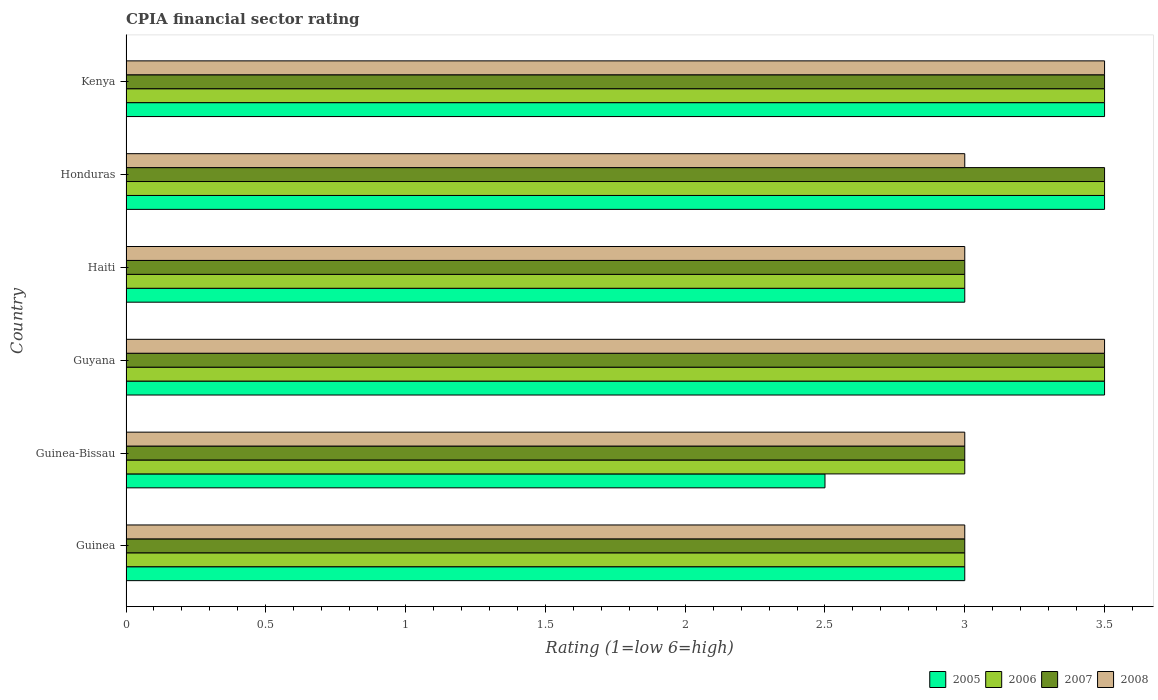How many groups of bars are there?
Your response must be concise. 6. Are the number of bars per tick equal to the number of legend labels?
Provide a short and direct response. Yes. How many bars are there on the 3rd tick from the top?
Offer a terse response. 4. How many bars are there on the 2nd tick from the bottom?
Your response must be concise. 4. What is the label of the 6th group of bars from the top?
Offer a very short reply. Guinea. Across all countries, what is the maximum CPIA rating in 2008?
Your answer should be very brief. 3.5. Across all countries, what is the minimum CPIA rating in 2008?
Keep it short and to the point. 3. In which country was the CPIA rating in 2007 maximum?
Ensure brevity in your answer.  Guyana. In which country was the CPIA rating in 2006 minimum?
Provide a succinct answer. Guinea. What is the total CPIA rating in 2006 in the graph?
Provide a succinct answer. 19.5. What is the difference between the CPIA rating in 2005 and CPIA rating in 2007 in Guyana?
Your answer should be very brief. 0. What is the ratio of the CPIA rating in 2007 in Guinea-Bissau to that in Honduras?
Your answer should be very brief. 0.86. What is the difference between the highest and the lowest CPIA rating in 2007?
Your answer should be compact. 0.5. In how many countries, is the CPIA rating in 2008 greater than the average CPIA rating in 2008 taken over all countries?
Give a very brief answer. 2. What does the 2nd bar from the bottom in Kenya represents?
Provide a short and direct response. 2006. Is it the case that in every country, the sum of the CPIA rating in 2008 and CPIA rating in 2005 is greater than the CPIA rating in 2007?
Provide a short and direct response. Yes. How many bars are there?
Give a very brief answer. 24. Are all the bars in the graph horizontal?
Keep it short and to the point. Yes. How many countries are there in the graph?
Provide a short and direct response. 6. What is the difference between two consecutive major ticks on the X-axis?
Your response must be concise. 0.5. Are the values on the major ticks of X-axis written in scientific E-notation?
Keep it short and to the point. No. Where does the legend appear in the graph?
Offer a very short reply. Bottom right. How are the legend labels stacked?
Your response must be concise. Horizontal. What is the title of the graph?
Offer a terse response. CPIA financial sector rating. What is the Rating (1=low 6=high) of 2007 in Guinea?
Give a very brief answer. 3. What is the Rating (1=low 6=high) of 2008 in Guinea?
Your answer should be very brief. 3. What is the Rating (1=low 6=high) in 2005 in Guinea-Bissau?
Offer a very short reply. 2.5. What is the Rating (1=low 6=high) in 2006 in Guinea-Bissau?
Provide a short and direct response. 3. What is the Rating (1=low 6=high) in 2007 in Guinea-Bissau?
Keep it short and to the point. 3. What is the Rating (1=low 6=high) in 2006 in Guyana?
Make the answer very short. 3.5. What is the Rating (1=low 6=high) in 2005 in Haiti?
Your response must be concise. 3. What is the Rating (1=low 6=high) in 2007 in Haiti?
Offer a terse response. 3. What is the Rating (1=low 6=high) in 2008 in Honduras?
Your answer should be very brief. 3. What is the Rating (1=low 6=high) in 2005 in Kenya?
Give a very brief answer. 3.5. What is the Rating (1=low 6=high) of 2008 in Kenya?
Your answer should be compact. 3.5. Across all countries, what is the maximum Rating (1=low 6=high) of 2006?
Ensure brevity in your answer.  3.5. Across all countries, what is the maximum Rating (1=low 6=high) in 2008?
Ensure brevity in your answer.  3.5. Across all countries, what is the minimum Rating (1=low 6=high) in 2006?
Ensure brevity in your answer.  3. What is the total Rating (1=low 6=high) in 2006 in the graph?
Offer a terse response. 19.5. What is the total Rating (1=low 6=high) of 2008 in the graph?
Give a very brief answer. 19. What is the difference between the Rating (1=low 6=high) in 2005 in Guinea and that in Guinea-Bissau?
Ensure brevity in your answer.  0.5. What is the difference between the Rating (1=low 6=high) of 2007 in Guinea and that in Guinea-Bissau?
Your answer should be compact. 0. What is the difference between the Rating (1=low 6=high) of 2008 in Guinea and that in Guinea-Bissau?
Your answer should be very brief. 0. What is the difference between the Rating (1=low 6=high) of 2008 in Guinea and that in Guyana?
Keep it short and to the point. -0.5. What is the difference between the Rating (1=low 6=high) in 2005 in Guinea and that in Honduras?
Offer a very short reply. -0.5. What is the difference between the Rating (1=low 6=high) of 2007 in Guinea and that in Honduras?
Your answer should be compact. -0.5. What is the difference between the Rating (1=low 6=high) in 2008 in Guinea and that in Honduras?
Your answer should be compact. 0. What is the difference between the Rating (1=low 6=high) of 2005 in Guinea and that in Kenya?
Keep it short and to the point. -0.5. What is the difference between the Rating (1=low 6=high) of 2006 in Guinea and that in Kenya?
Provide a succinct answer. -0.5. What is the difference between the Rating (1=low 6=high) of 2007 in Guinea and that in Kenya?
Provide a short and direct response. -0.5. What is the difference between the Rating (1=low 6=high) of 2008 in Guinea-Bissau and that in Guyana?
Provide a short and direct response. -0.5. What is the difference between the Rating (1=low 6=high) of 2005 in Guinea-Bissau and that in Haiti?
Keep it short and to the point. -0.5. What is the difference between the Rating (1=low 6=high) in 2005 in Guinea-Bissau and that in Honduras?
Make the answer very short. -1. What is the difference between the Rating (1=low 6=high) of 2007 in Guinea-Bissau and that in Honduras?
Your response must be concise. -0.5. What is the difference between the Rating (1=low 6=high) in 2006 in Guinea-Bissau and that in Kenya?
Ensure brevity in your answer.  -0.5. What is the difference between the Rating (1=low 6=high) of 2007 in Guinea-Bissau and that in Kenya?
Your answer should be very brief. -0.5. What is the difference between the Rating (1=low 6=high) of 2008 in Guinea-Bissau and that in Kenya?
Provide a succinct answer. -0.5. What is the difference between the Rating (1=low 6=high) of 2005 in Guyana and that in Honduras?
Make the answer very short. 0. What is the difference between the Rating (1=low 6=high) of 2006 in Guyana and that in Honduras?
Give a very brief answer. 0. What is the difference between the Rating (1=low 6=high) of 2005 in Guyana and that in Kenya?
Your response must be concise. 0. What is the difference between the Rating (1=low 6=high) in 2007 in Guyana and that in Kenya?
Your response must be concise. 0. What is the difference between the Rating (1=low 6=high) of 2008 in Guyana and that in Kenya?
Offer a terse response. 0. What is the difference between the Rating (1=low 6=high) of 2005 in Haiti and that in Honduras?
Give a very brief answer. -0.5. What is the difference between the Rating (1=low 6=high) in 2006 in Haiti and that in Honduras?
Make the answer very short. -0.5. What is the difference between the Rating (1=low 6=high) of 2007 in Haiti and that in Honduras?
Keep it short and to the point. -0.5. What is the difference between the Rating (1=low 6=high) in 2005 in Haiti and that in Kenya?
Provide a succinct answer. -0.5. What is the difference between the Rating (1=low 6=high) in 2007 in Haiti and that in Kenya?
Ensure brevity in your answer.  -0.5. What is the difference between the Rating (1=low 6=high) in 2008 in Haiti and that in Kenya?
Make the answer very short. -0.5. What is the difference between the Rating (1=low 6=high) of 2005 in Honduras and that in Kenya?
Ensure brevity in your answer.  0. What is the difference between the Rating (1=low 6=high) in 2007 in Honduras and that in Kenya?
Ensure brevity in your answer.  0. What is the difference between the Rating (1=low 6=high) of 2005 in Guinea and the Rating (1=low 6=high) of 2006 in Guinea-Bissau?
Your answer should be compact. 0. What is the difference between the Rating (1=low 6=high) in 2005 in Guinea and the Rating (1=low 6=high) in 2008 in Guinea-Bissau?
Make the answer very short. 0. What is the difference between the Rating (1=low 6=high) in 2006 in Guinea and the Rating (1=low 6=high) in 2007 in Guinea-Bissau?
Make the answer very short. 0. What is the difference between the Rating (1=low 6=high) of 2007 in Guinea and the Rating (1=low 6=high) of 2008 in Guinea-Bissau?
Your answer should be compact. 0. What is the difference between the Rating (1=low 6=high) in 2006 in Guinea and the Rating (1=low 6=high) in 2007 in Guyana?
Your answer should be very brief. -0.5. What is the difference between the Rating (1=low 6=high) in 2007 in Guinea and the Rating (1=low 6=high) in 2008 in Guyana?
Provide a short and direct response. -0.5. What is the difference between the Rating (1=low 6=high) in 2005 in Guinea and the Rating (1=low 6=high) in 2006 in Haiti?
Ensure brevity in your answer.  0. What is the difference between the Rating (1=low 6=high) in 2006 in Guinea and the Rating (1=low 6=high) in 2008 in Haiti?
Make the answer very short. 0. What is the difference between the Rating (1=low 6=high) of 2005 in Guinea and the Rating (1=low 6=high) of 2007 in Honduras?
Offer a very short reply. -0.5. What is the difference between the Rating (1=low 6=high) in 2006 in Guinea and the Rating (1=low 6=high) in 2007 in Honduras?
Your answer should be very brief. -0.5. What is the difference between the Rating (1=low 6=high) in 2006 in Guinea and the Rating (1=low 6=high) in 2008 in Honduras?
Keep it short and to the point. 0. What is the difference between the Rating (1=low 6=high) in 2006 in Guinea and the Rating (1=low 6=high) in 2007 in Kenya?
Provide a short and direct response. -0.5. What is the difference between the Rating (1=low 6=high) of 2006 in Guinea and the Rating (1=low 6=high) of 2008 in Kenya?
Provide a short and direct response. -0.5. What is the difference between the Rating (1=low 6=high) of 2007 in Guinea and the Rating (1=low 6=high) of 2008 in Kenya?
Ensure brevity in your answer.  -0.5. What is the difference between the Rating (1=low 6=high) of 2005 in Guinea-Bissau and the Rating (1=low 6=high) of 2007 in Guyana?
Offer a very short reply. -1. What is the difference between the Rating (1=low 6=high) in 2005 in Guinea-Bissau and the Rating (1=low 6=high) in 2008 in Guyana?
Your answer should be compact. -1. What is the difference between the Rating (1=low 6=high) in 2007 in Guinea-Bissau and the Rating (1=low 6=high) in 2008 in Guyana?
Your answer should be compact. -0.5. What is the difference between the Rating (1=low 6=high) in 2005 in Guinea-Bissau and the Rating (1=low 6=high) in 2007 in Haiti?
Make the answer very short. -0.5. What is the difference between the Rating (1=low 6=high) in 2005 in Guinea-Bissau and the Rating (1=low 6=high) in 2008 in Haiti?
Offer a terse response. -0.5. What is the difference between the Rating (1=low 6=high) in 2006 in Guinea-Bissau and the Rating (1=low 6=high) in 2007 in Haiti?
Provide a succinct answer. 0. What is the difference between the Rating (1=low 6=high) in 2006 in Guinea-Bissau and the Rating (1=low 6=high) in 2008 in Haiti?
Your answer should be very brief. 0. What is the difference between the Rating (1=low 6=high) in 2005 in Guinea-Bissau and the Rating (1=low 6=high) in 2006 in Honduras?
Keep it short and to the point. -1. What is the difference between the Rating (1=low 6=high) of 2005 in Guinea-Bissau and the Rating (1=low 6=high) of 2007 in Honduras?
Offer a very short reply. -1. What is the difference between the Rating (1=low 6=high) of 2005 in Guinea-Bissau and the Rating (1=low 6=high) of 2008 in Honduras?
Offer a terse response. -0.5. What is the difference between the Rating (1=low 6=high) of 2006 in Guinea-Bissau and the Rating (1=low 6=high) of 2007 in Honduras?
Keep it short and to the point. -0.5. What is the difference between the Rating (1=low 6=high) of 2007 in Guinea-Bissau and the Rating (1=low 6=high) of 2008 in Honduras?
Offer a terse response. 0. What is the difference between the Rating (1=low 6=high) of 2006 in Guinea-Bissau and the Rating (1=low 6=high) of 2007 in Kenya?
Give a very brief answer. -0.5. What is the difference between the Rating (1=low 6=high) in 2006 in Guinea-Bissau and the Rating (1=low 6=high) in 2008 in Kenya?
Ensure brevity in your answer.  -0.5. What is the difference between the Rating (1=low 6=high) of 2007 in Guinea-Bissau and the Rating (1=low 6=high) of 2008 in Kenya?
Offer a very short reply. -0.5. What is the difference between the Rating (1=low 6=high) in 2005 in Guyana and the Rating (1=low 6=high) in 2006 in Haiti?
Offer a very short reply. 0.5. What is the difference between the Rating (1=low 6=high) of 2005 in Guyana and the Rating (1=low 6=high) of 2007 in Haiti?
Make the answer very short. 0.5. What is the difference between the Rating (1=low 6=high) of 2005 in Guyana and the Rating (1=low 6=high) of 2008 in Haiti?
Your answer should be very brief. 0.5. What is the difference between the Rating (1=low 6=high) in 2006 in Guyana and the Rating (1=low 6=high) in 2007 in Haiti?
Keep it short and to the point. 0.5. What is the difference between the Rating (1=low 6=high) in 2006 in Guyana and the Rating (1=low 6=high) in 2008 in Haiti?
Your response must be concise. 0.5. What is the difference between the Rating (1=low 6=high) of 2007 in Guyana and the Rating (1=low 6=high) of 2008 in Haiti?
Keep it short and to the point. 0.5. What is the difference between the Rating (1=low 6=high) in 2005 in Guyana and the Rating (1=low 6=high) in 2007 in Honduras?
Make the answer very short. 0. What is the difference between the Rating (1=low 6=high) in 2006 in Guyana and the Rating (1=low 6=high) in 2007 in Honduras?
Your response must be concise. 0. What is the difference between the Rating (1=low 6=high) in 2006 in Guyana and the Rating (1=low 6=high) in 2008 in Honduras?
Offer a very short reply. 0.5. What is the difference between the Rating (1=low 6=high) of 2007 in Guyana and the Rating (1=low 6=high) of 2008 in Honduras?
Offer a terse response. 0.5. What is the difference between the Rating (1=low 6=high) of 2005 in Guyana and the Rating (1=low 6=high) of 2006 in Kenya?
Make the answer very short. 0. What is the difference between the Rating (1=low 6=high) of 2005 in Guyana and the Rating (1=low 6=high) of 2007 in Kenya?
Make the answer very short. 0. What is the difference between the Rating (1=low 6=high) in 2007 in Guyana and the Rating (1=low 6=high) in 2008 in Kenya?
Keep it short and to the point. 0. What is the difference between the Rating (1=low 6=high) in 2006 in Haiti and the Rating (1=low 6=high) in 2007 in Honduras?
Give a very brief answer. -0.5. What is the difference between the Rating (1=low 6=high) of 2005 in Haiti and the Rating (1=low 6=high) of 2006 in Kenya?
Ensure brevity in your answer.  -0.5. What is the difference between the Rating (1=low 6=high) in 2005 in Haiti and the Rating (1=low 6=high) in 2007 in Kenya?
Provide a short and direct response. -0.5. What is the difference between the Rating (1=low 6=high) of 2005 in Honduras and the Rating (1=low 6=high) of 2008 in Kenya?
Ensure brevity in your answer.  0. What is the average Rating (1=low 6=high) in 2005 per country?
Keep it short and to the point. 3.17. What is the average Rating (1=low 6=high) in 2007 per country?
Provide a succinct answer. 3.25. What is the average Rating (1=low 6=high) in 2008 per country?
Offer a terse response. 3.17. What is the difference between the Rating (1=low 6=high) in 2005 and Rating (1=low 6=high) in 2008 in Guinea?
Offer a very short reply. 0. What is the difference between the Rating (1=low 6=high) of 2006 and Rating (1=low 6=high) of 2008 in Guinea?
Your answer should be very brief. 0. What is the difference between the Rating (1=low 6=high) in 2005 and Rating (1=low 6=high) in 2008 in Guinea-Bissau?
Your response must be concise. -0.5. What is the difference between the Rating (1=low 6=high) in 2006 and Rating (1=low 6=high) in 2007 in Guinea-Bissau?
Offer a very short reply. 0. What is the difference between the Rating (1=low 6=high) of 2005 and Rating (1=low 6=high) of 2006 in Guyana?
Ensure brevity in your answer.  0. What is the difference between the Rating (1=low 6=high) of 2005 and Rating (1=low 6=high) of 2007 in Guyana?
Provide a short and direct response. 0. What is the difference between the Rating (1=low 6=high) in 2005 and Rating (1=low 6=high) in 2008 in Guyana?
Ensure brevity in your answer.  0. What is the difference between the Rating (1=low 6=high) in 2006 and Rating (1=low 6=high) in 2008 in Guyana?
Offer a very short reply. 0. What is the difference between the Rating (1=low 6=high) in 2005 and Rating (1=low 6=high) in 2006 in Haiti?
Offer a terse response. 0. What is the difference between the Rating (1=low 6=high) of 2006 and Rating (1=low 6=high) of 2008 in Haiti?
Offer a terse response. 0. What is the difference between the Rating (1=low 6=high) of 2006 and Rating (1=low 6=high) of 2007 in Honduras?
Give a very brief answer. 0. What is the difference between the Rating (1=low 6=high) in 2006 and Rating (1=low 6=high) in 2008 in Honduras?
Offer a very short reply. 0.5. What is the difference between the Rating (1=low 6=high) in 2007 and Rating (1=low 6=high) in 2008 in Honduras?
Make the answer very short. 0.5. What is the difference between the Rating (1=low 6=high) of 2005 and Rating (1=low 6=high) of 2007 in Kenya?
Your answer should be very brief. 0. What is the difference between the Rating (1=low 6=high) of 2007 and Rating (1=low 6=high) of 2008 in Kenya?
Keep it short and to the point. 0. What is the ratio of the Rating (1=low 6=high) of 2005 in Guinea to that in Guyana?
Your response must be concise. 0.86. What is the ratio of the Rating (1=low 6=high) of 2006 in Guinea to that in Guyana?
Ensure brevity in your answer.  0.86. What is the ratio of the Rating (1=low 6=high) in 2007 in Guinea to that in Guyana?
Offer a very short reply. 0.86. What is the ratio of the Rating (1=low 6=high) of 2008 in Guinea to that in Guyana?
Provide a short and direct response. 0.86. What is the ratio of the Rating (1=low 6=high) in 2008 in Guinea to that in Haiti?
Provide a succinct answer. 1. What is the ratio of the Rating (1=low 6=high) of 2007 in Guinea to that in Honduras?
Your response must be concise. 0.86. What is the ratio of the Rating (1=low 6=high) of 2008 in Guinea to that in Kenya?
Your answer should be very brief. 0.86. What is the ratio of the Rating (1=low 6=high) of 2005 in Guinea-Bissau to that in Guyana?
Provide a short and direct response. 0.71. What is the ratio of the Rating (1=low 6=high) of 2006 in Guinea-Bissau to that in Guyana?
Make the answer very short. 0.86. What is the ratio of the Rating (1=low 6=high) of 2008 in Guinea-Bissau to that in Honduras?
Provide a succinct answer. 1. What is the ratio of the Rating (1=low 6=high) of 2005 in Guinea-Bissau to that in Kenya?
Your answer should be very brief. 0.71. What is the ratio of the Rating (1=low 6=high) of 2006 in Guinea-Bissau to that in Kenya?
Provide a short and direct response. 0.86. What is the ratio of the Rating (1=low 6=high) of 2007 in Guinea-Bissau to that in Kenya?
Ensure brevity in your answer.  0.86. What is the ratio of the Rating (1=low 6=high) in 2008 in Guinea-Bissau to that in Kenya?
Offer a very short reply. 0.86. What is the ratio of the Rating (1=low 6=high) of 2005 in Guyana to that in Haiti?
Provide a short and direct response. 1.17. What is the ratio of the Rating (1=low 6=high) in 2006 in Guyana to that in Honduras?
Keep it short and to the point. 1. What is the ratio of the Rating (1=low 6=high) in 2007 in Guyana to that in Honduras?
Provide a succinct answer. 1. What is the ratio of the Rating (1=low 6=high) of 2008 in Guyana to that in Honduras?
Keep it short and to the point. 1.17. What is the ratio of the Rating (1=low 6=high) in 2007 in Guyana to that in Kenya?
Keep it short and to the point. 1. What is the ratio of the Rating (1=low 6=high) of 2008 in Guyana to that in Kenya?
Make the answer very short. 1. What is the ratio of the Rating (1=low 6=high) of 2005 in Haiti to that in Honduras?
Offer a very short reply. 0.86. What is the ratio of the Rating (1=low 6=high) of 2006 in Haiti to that in Honduras?
Ensure brevity in your answer.  0.86. What is the ratio of the Rating (1=low 6=high) in 2007 in Haiti to that in Honduras?
Your answer should be very brief. 0.86. What is the ratio of the Rating (1=low 6=high) of 2005 in Honduras to that in Kenya?
Offer a terse response. 1. What is the ratio of the Rating (1=low 6=high) in 2006 in Honduras to that in Kenya?
Make the answer very short. 1. What is the ratio of the Rating (1=low 6=high) in 2007 in Honduras to that in Kenya?
Your answer should be compact. 1. What is the ratio of the Rating (1=low 6=high) of 2008 in Honduras to that in Kenya?
Provide a succinct answer. 0.86. What is the difference between the highest and the second highest Rating (1=low 6=high) in 2005?
Your response must be concise. 0. What is the difference between the highest and the second highest Rating (1=low 6=high) of 2006?
Provide a succinct answer. 0. What is the difference between the highest and the second highest Rating (1=low 6=high) in 2007?
Your response must be concise. 0. What is the difference between the highest and the second highest Rating (1=low 6=high) in 2008?
Make the answer very short. 0. 